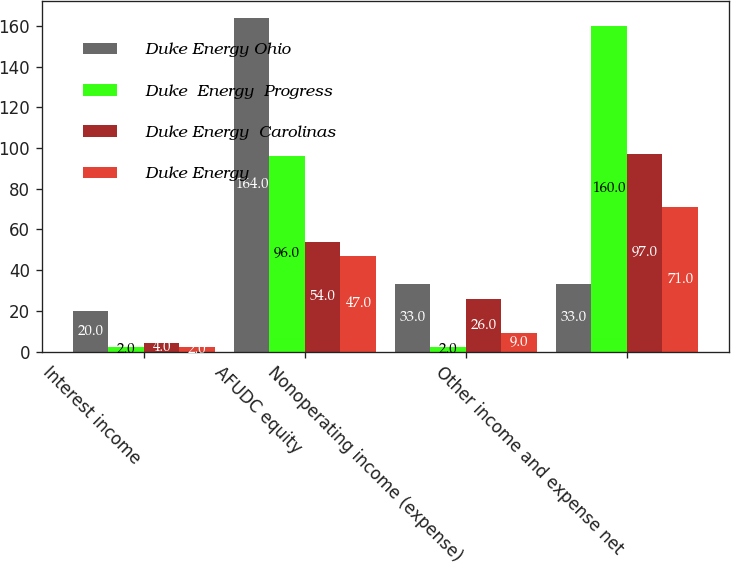<chart> <loc_0><loc_0><loc_500><loc_500><stacked_bar_chart><ecel><fcel>Interest income<fcel>AFUDC equity<fcel>Nonoperating income (expense)<fcel>Other income and expense net<nl><fcel>Duke Energy Ohio<fcel>20<fcel>164<fcel>33<fcel>33<nl><fcel>Duke  Energy  Progress<fcel>2<fcel>96<fcel>2<fcel>160<nl><fcel>Duke Energy  Carolinas<fcel>4<fcel>54<fcel>26<fcel>97<nl><fcel>Duke Energy<fcel>2<fcel>47<fcel>9<fcel>71<nl></chart> 